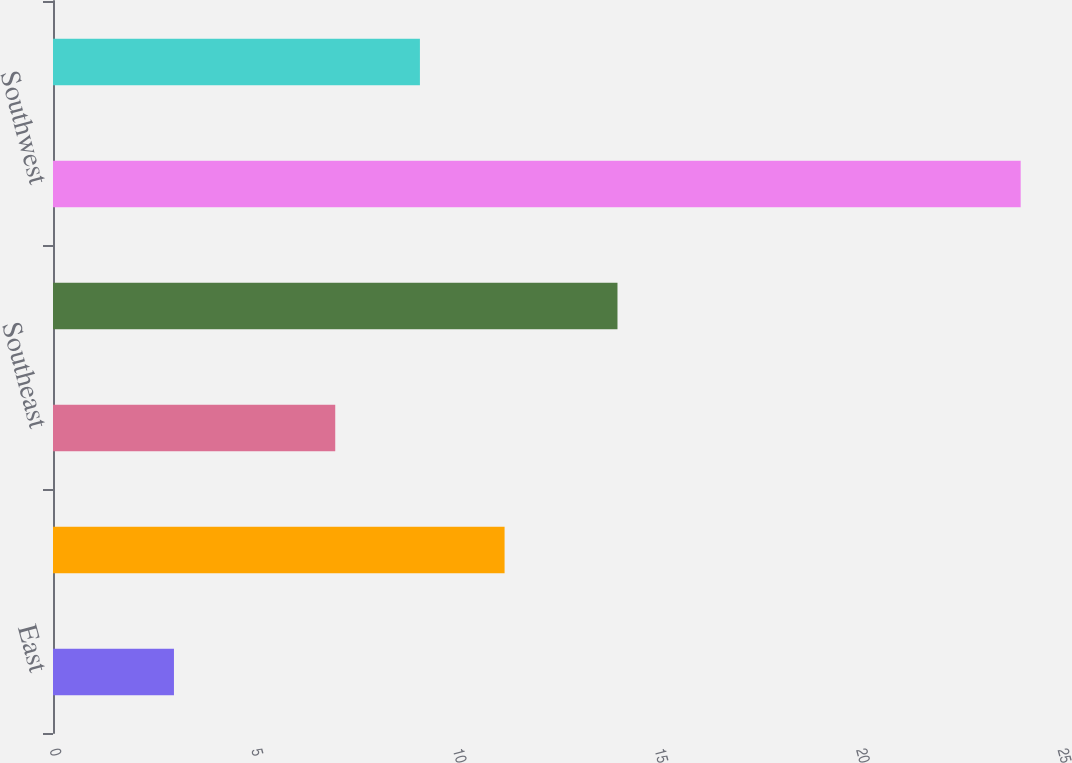<chart> <loc_0><loc_0><loc_500><loc_500><bar_chart><fcel>East<fcel>Midwest<fcel>Southeast<fcel>South Central<fcel>Southwest<fcel>West<nl><fcel>3<fcel>11.2<fcel>7<fcel>14<fcel>24<fcel>9.1<nl></chart> 